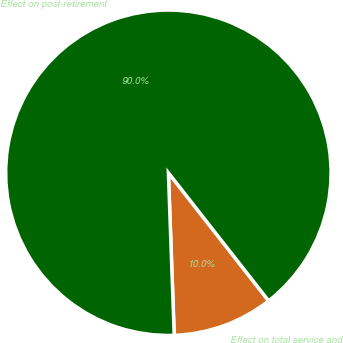Convert chart. <chart><loc_0><loc_0><loc_500><loc_500><pie_chart><fcel>Effect on total service and<fcel>Effect on post-retirement<nl><fcel>10.0%<fcel>90.0%<nl></chart> 